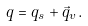Convert formula to latex. <formula><loc_0><loc_0><loc_500><loc_500>q = q _ { s } + { \vec { q } } _ { v } .</formula> 